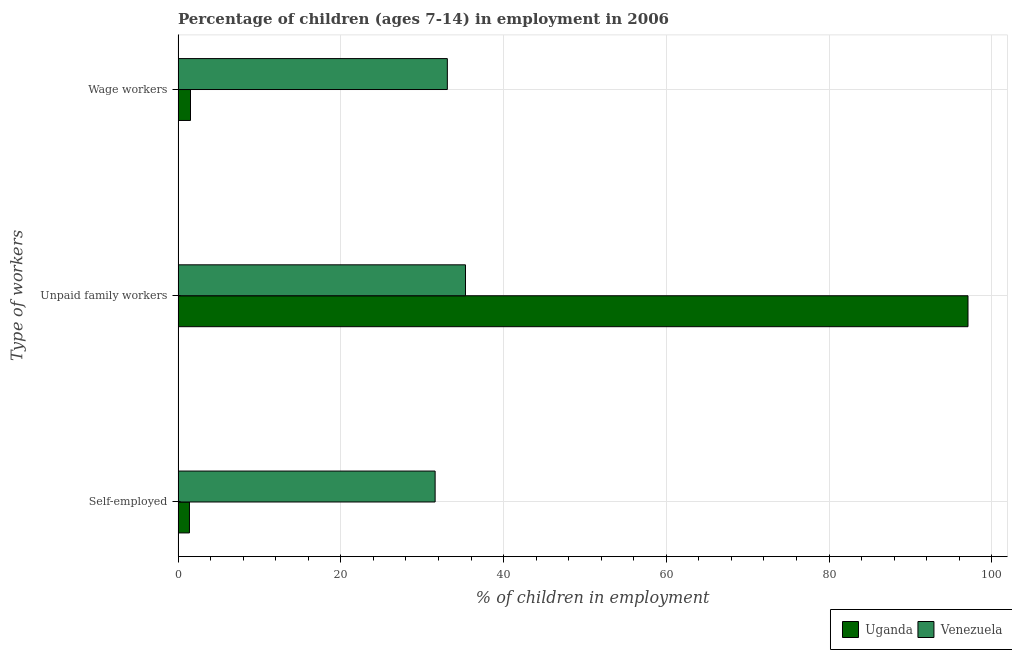What is the label of the 3rd group of bars from the top?
Provide a succinct answer. Self-employed. What is the percentage of children employed as unpaid family workers in Uganda?
Your response must be concise. 97.07. Across all countries, what is the maximum percentage of self employed children?
Your answer should be compact. 31.59. Across all countries, what is the minimum percentage of children employed as unpaid family workers?
Make the answer very short. 35.32. In which country was the percentage of self employed children maximum?
Provide a short and direct response. Venezuela. In which country was the percentage of children employed as wage workers minimum?
Your answer should be very brief. Uganda. What is the total percentage of self employed children in the graph?
Your answer should be very brief. 32.99. What is the difference between the percentage of children employed as wage workers in Venezuela and that in Uganda?
Provide a short and direct response. 31.56. What is the difference between the percentage of children employed as unpaid family workers in Venezuela and the percentage of self employed children in Uganda?
Give a very brief answer. 33.92. What is the average percentage of self employed children per country?
Give a very brief answer. 16.5. What is the difference between the percentage of children employed as wage workers and percentage of children employed as unpaid family workers in Venezuela?
Your response must be concise. -2.23. In how many countries, is the percentage of children employed as unpaid family workers greater than 12 %?
Your response must be concise. 2. What is the ratio of the percentage of children employed as unpaid family workers in Uganda to that in Venezuela?
Make the answer very short. 2.75. Is the difference between the percentage of self employed children in Uganda and Venezuela greater than the difference between the percentage of children employed as unpaid family workers in Uganda and Venezuela?
Your answer should be very brief. No. What is the difference between the highest and the second highest percentage of self employed children?
Your answer should be compact. 30.19. What is the difference between the highest and the lowest percentage of children employed as unpaid family workers?
Give a very brief answer. 61.75. What does the 2nd bar from the top in Wage workers represents?
Offer a terse response. Uganda. What does the 1st bar from the bottom in Self-employed represents?
Provide a succinct answer. Uganda. Is it the case that in every country, the sum of the percentage of self employed children and percentage of children employed as unpaid family workers is greater than the percentage of children employed as wage workers?
Provide a short and direct response. Yes. How many bars are there?
Make the answer very short. 6. What is the difference between two consecutive major ticks on the X-axis?
Your response must be concise. 20. Are the values on the major ticks of X-axis written in scientific E-notation?
Your answer should be very brief. No. Does the graph contain any zero values?
Offer a very short reply. No. Where does the legend appear in the graph?
Offer a terse response. Bottom right. How many legend labels are there?
Provide a succinct answer. 2. How are the legend labels stacked?
Offer a very short reply. Horizontal. What is the title of the graph?
Your answer should be very brief. Percentage of children (ages 7-14) in employment in 2006. What is the label or title of the X-axis?
Ensure brevity in your answer.  % of children in employment. What is the label or title of the Y-axis?
Provide a succinct answer. Type of workers. What is the % of children in employment of Venezuela in Self-employed?
Offer a very short reply. 31.59. What is the % of children in employment in Uganda in Unpaid family workers?
Keep it short and to the point. 97.07. What is the % of children in employment of Venezuela in Unpaid family workers?
Your answer should be compact. 35.32. What is the % of children in employment in Uganda in Wage workers?
Your response must be concise. 1.53. What is the % of children in employment of Venezuela in Wage workers?
Your answer should be very brief. 33.09. Across all Type of workers, what is the maximum % of children in employment of Uganda?
Offer a very short reply. 97.07. Across all Type of workers, what is the maximum % of children in employment of Venezuela?
Provide a short and direct response. 35.32. Across all Type of workers, what is the minimum % of children in employment in Uganda?
Provide a succinct answer. 1.4. Across all Type of workers, what is the minimum % of children in employment of Venezuela?
Provide a succinct answer. 31.59. What is the difference between the % of children in employment of Uganda in Self-employed and that in Unpaid family workers?
Provide a short and direct response. -95.67. What is the difference between the % of children in employment of Venezuela in Self-employed and that in Unpaid family workers?
Provide a succinct answer. -3.73. What is the difference between the % of children in employment in Uganda in Self-employed and that in Wage workers?
Your response must be concise. -0.13. What is the difference between the % of children in employment of Uganda in Unpaid family workers and that in Wage workers?
Make the answer very short. 95.54. What is the difference between the % of children in employment in Venezuela in Unpaid family workers and that in Wage workers?
Your response must be concise. 2.23. What is the difference between the % of children in employment of Uganda in Self-employed and the % of children in employment of Venezuela in Unpaid family workers?
Keep it short and to the point. -33.92. What is the difference between the % of children in employment of Uganda in Self-employed and the % of children in employment of Venezuela in Wage workers?
Provide a succinct answer. -31.69. What is the difference between the % of children in employment of Uganda in Unpaid family workers and the % of children in employment of Venezuela in Wage workers?
Offer a terse response. 63.98. What is the average % of children in employment of Uganda per Type of workers?
Offer a terse response. 33.33. What is the average % of children in employment in Venezuela per Type of workers?
Provide a succinct answer. 33.33. What is the difference between the % of children in employment of Uganda and % of children in employment of Venezuela in Self-employed?
Your answer should be compact. -30.19. What is the difference between the % of children in employment of Uganda and % of children in employment of Venezuela in Unpaid family workers?
Your response must be concise. 61.75. What is the difference between the % of children in employment of Uganda and % of children in employment of Venezuela in Wage workers?
Your response must be concise. -31.56. What is the ratio of the % of children in employment of Uganda in Self-employed to that in Unpaid family workers?
Offer a terse response. 0.01. What is the ratio of the % of children in employment of Venezuela in Self-employed to that in Unpaid family workers?
Give a very brief answer. 0.89. What is the ratio of the % of children in employment in Uganda in Self-employed to that in Wage workers?
Your response must be concise. 0.92. What is the ratio of the % of children in employment of Venezuela in Self-employed to that in Wage workers?
Provide a short and direct response. 0.95. What is the ratio of the % of children in employment in Uganda in Unpaid family workers to that in Wage workers?
Give a very brief answer. 63.44. What is the ratio of the % of children in employment of Venezuela in Unpaid family workers to that in Wage workers?
Make the answer very short. 1.07. What is the difference between the highest and the second highest % of children in employment of Uganda?
Provide a succinct answer. 95.54. What is the difference between the highest and the second highest % of children in employment in Venezuela?
Your response must be concise. 2.23. What is the difference between the highest and the lowest % of children in employment of Uganda?
Your response must be concise. 95.67. What is the difference between the highest and the lowest % of children in employment in Venezuela?
Ensure brevity in your answer.  3.73. 